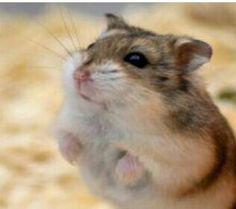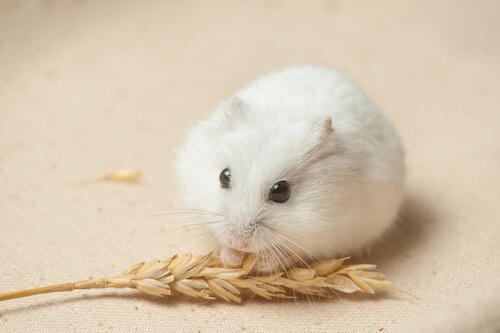The first image is the image on the left, the second image is the image on the right. Considering the images on both sides, is "A single rodent is lying down on a smooth surface in the image on the right." valid? Answer yes or no. Yes. The first image is the image on the left, the second image is the image on the right. Considering the images on both sides, is "Each image contains a single hamster, and at least one hamster is standing upright with its front paws in front of its body." valid? Answer yes or no. Yes. 